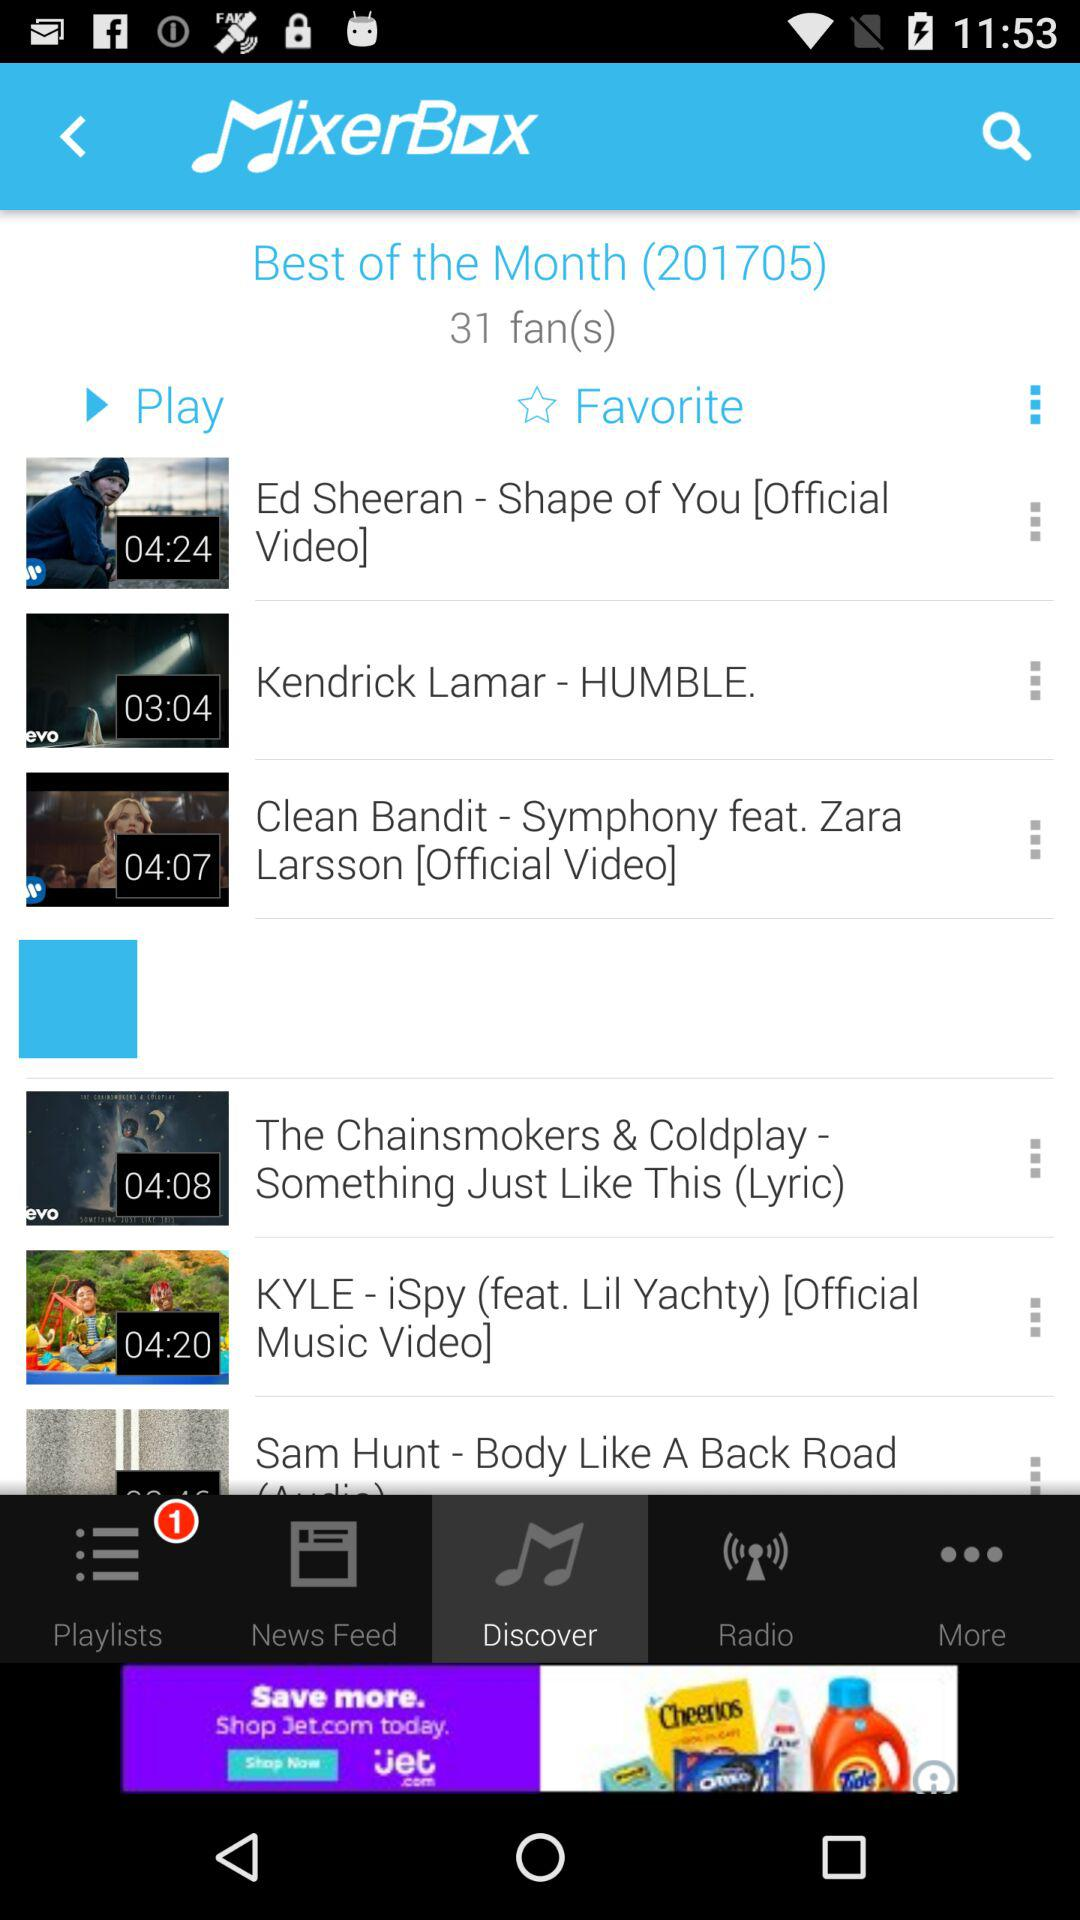How many new notifications are there in "Playlists"? There is 1 new notification. 